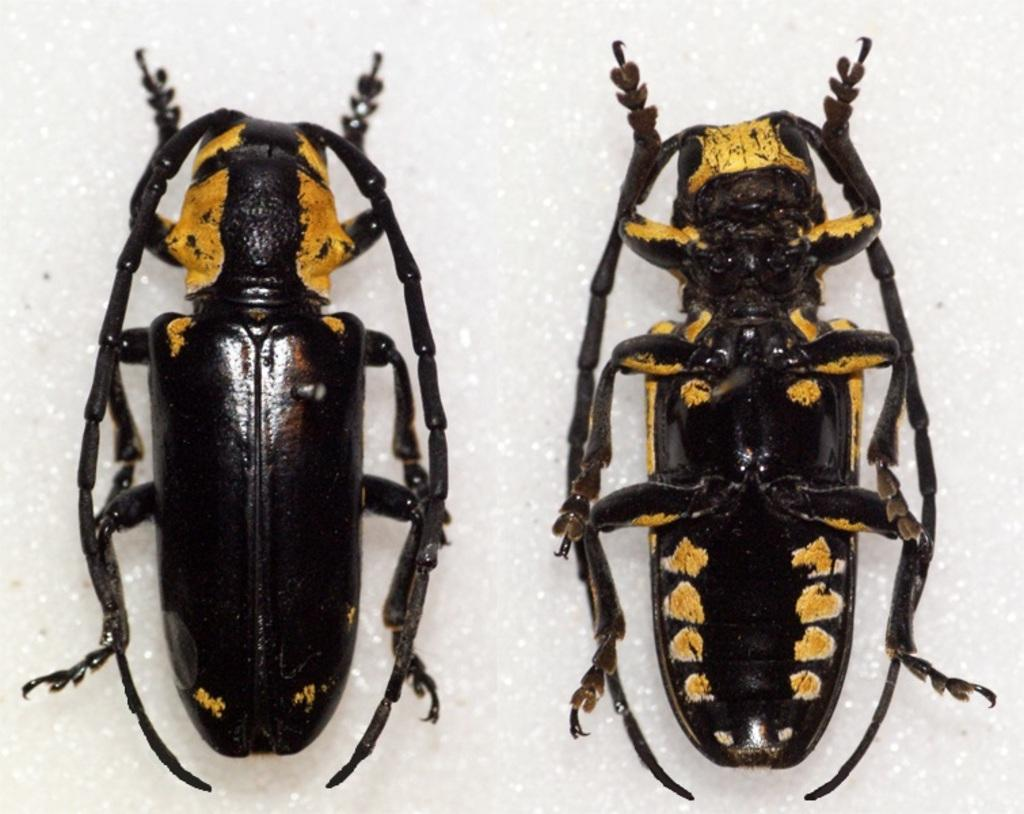How many insects are present in the image? There are two insects in the image. What colors can be seen on the insects? The insects are in black and yellow colors. What type of treatment is being administered to the insects in the image? There is no treatment being administered to the insects in the image; they are simply depicted in their natural state. 